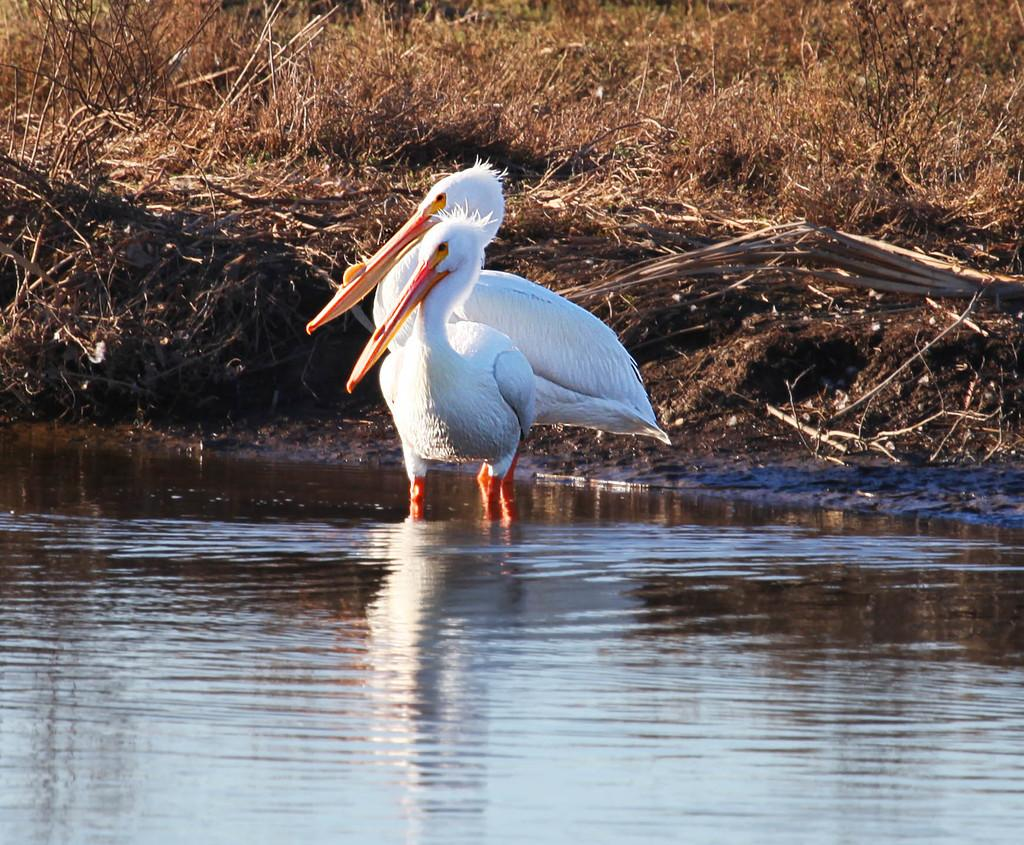What is at the bottom of the image? There is water at the bottom of the image. What can be seen in the middle of the image? There are cranes in the middle of the image. What type of vegetation is visible in the background of the image? There are plants in the background of the image. Can you see the face of the person who is thrilled about the meeting in the image? There is no person or meeting present in the image, so it is not possible to see a face or determine if someone is thrilled about a meeting. 